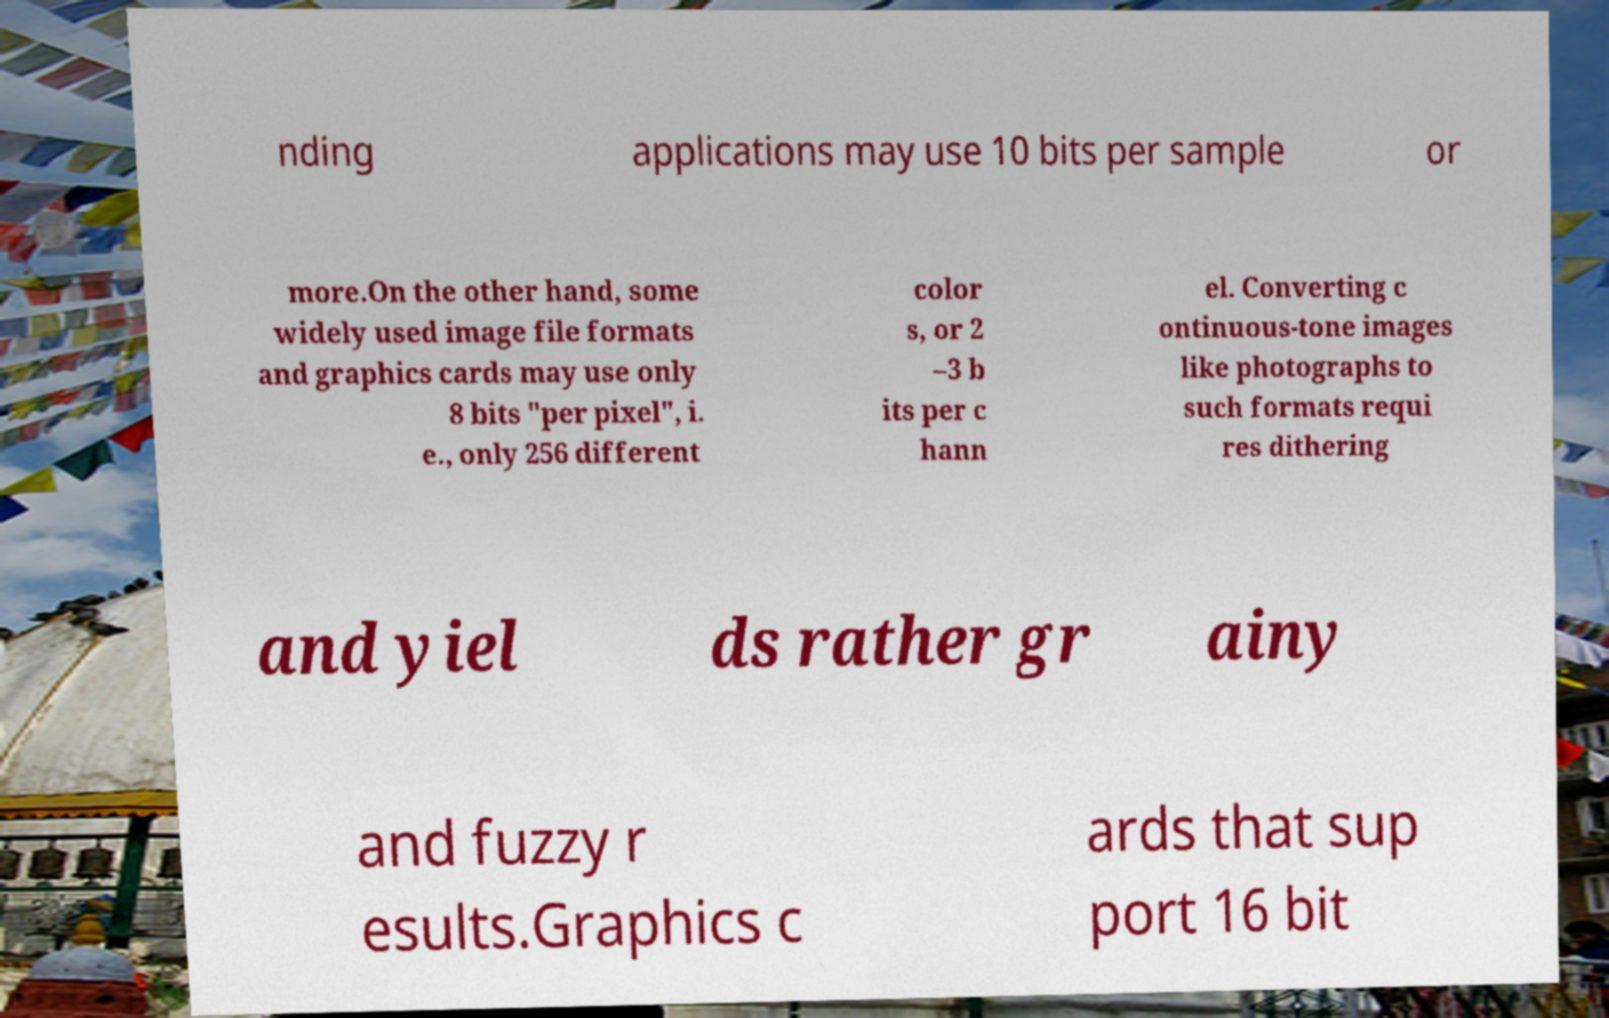Please read and relay the text visible in this image. What does it say? nding applications may use 10 bits per sample or more.On the other hand, some widely used image file formats and graphics cards may use only 8 bits "per pixel", i. e., only 256 different color s, or 2 –3 b its per c hann el. Converting c ontinuous-tone images like photographs to such formats requi res dithering and yiel ds rather gr ainy and fuzzy r esults.Graphics c ards that sup port 16 bit 